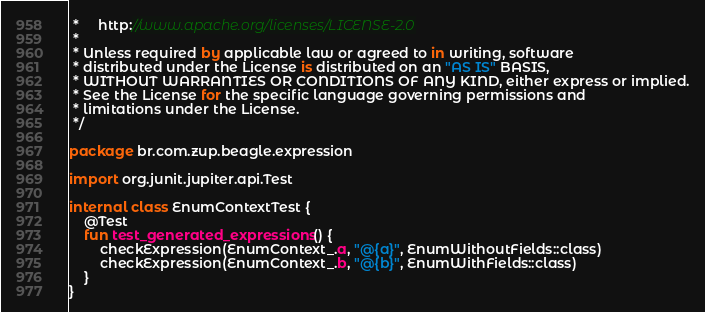Convert code to text. <code><loc_0><loc_0><loc_500><loc_500><_Kotlin_> *     http://www.apache.org/licenses/LICENSE-2.0
 *
 * Unless required by applicable law or agreed to in writing, software
 * distributed under the License is distributed on an "AS IS" BASIS,
 * WITHOUT WARRANTIES OR CONDITIONS OF ANY KIND, either express or implied.
 * See the License for the specific language governing permissions and
 * limitations under the License.
 */

package br.com.zup.beagle.expression

import org.junit.jupiter.api.Test

internal class EnumContextTest {
    @Test
    fun test_generated_expressions() {
        checkExpression(EnumContext_.a, "@{a}", EnumWithoutFields::class)
        checkExpression(EnumContext_.b, "@{b}", EnumWithFields::class)
    }
}</code> 